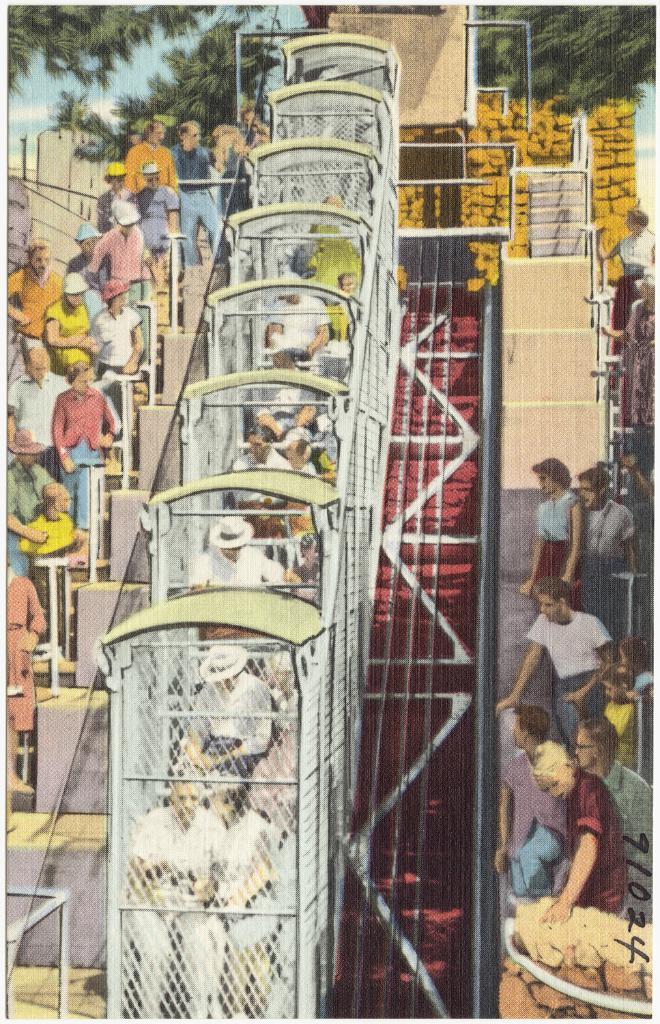In one or two sentences, can you explain what this image depicts? As we can see in the image there is drawing of few people here and there, stairs, trees and sky. 